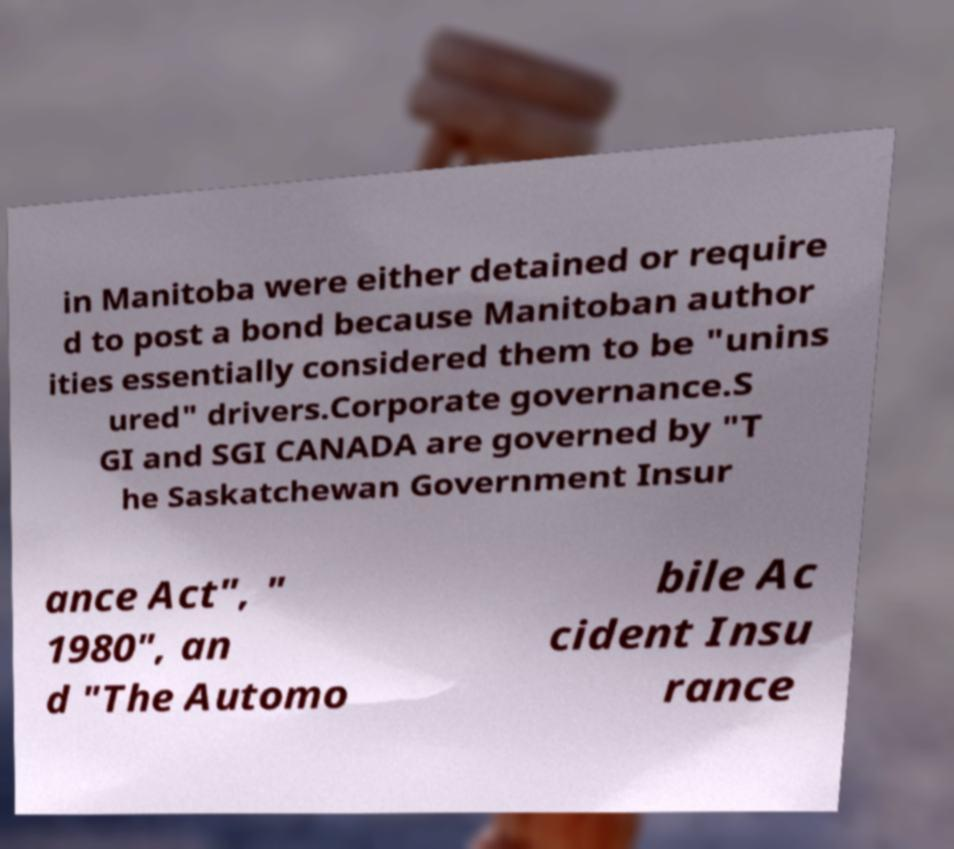What messages or text are displayed in this image? I need them in a readable, typed format. in Manitoba were either detained or require d to post a bond because Manitoban author ities essentially considered them to be "unins ured" drivers.Corporate governance.S GI and SGI CANADA are governed by "T he Saskatchewan Government Insur ance Act", " 1980", an d "The Automo bile Ac cident Insu rance 